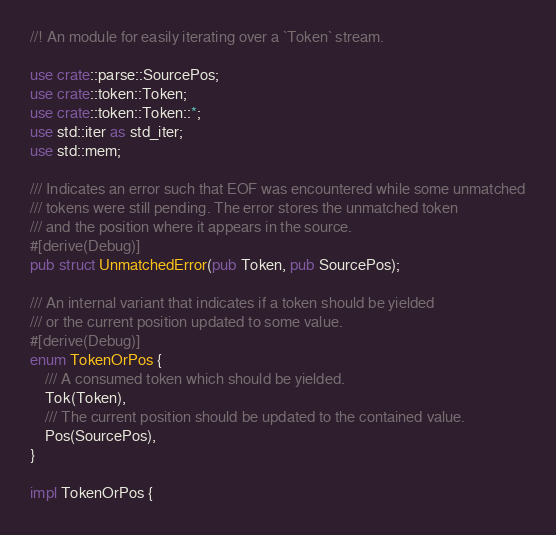Convert code to text. <code><loc_0><loc_0><loc_500><loc_500><_Rust_>//! An module for easily iterating over a `Token` stream.

use crate::parse::SourcePos;
use crate::token::Token;
use crate::token::Token::*;
use std::iter as std_iter;
use std::mem;

/// Indicates an error such that EOF was encountered while some unmatched
/// tokens were still pending. The error stores the unmatched token
/// and the position where it appears in the source.
#[derive(Debug)]
pub struct UnmatchedError(pub Token, pub SourcePos);

/// An internal variant that indicates if a token should be yielded
/// or the current position updated to some value.
#[derive(Debug)]
enum TokenOrPos {
    /// A consumed token which should be yielded.
    Tok(Token),
    /// The current position should be updated to the contained value.
    Pos(SourcePos),
}

impl TokenOrPos {</code> 